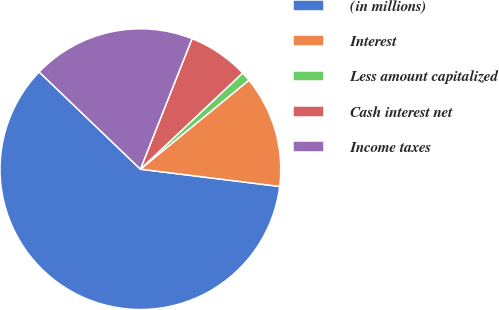Convert chart. <chart><loc_0><loc_0><loc_500><loc_500><pie_chart><fcel>(in millions)<fcel>Interest<fcel>Less amount capitalized<fcel>Cash interest net<fcel>Income taxes<nl><fcel>60.21%<fcel>12.9%<fcel>1.08%<fcel>6.99%<fcel>18.82%<nl></chart> 